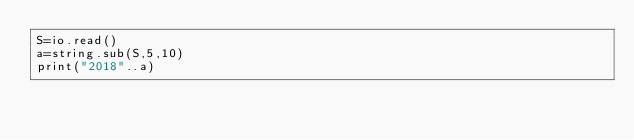Convert code to text. <code><loc_0><loc_0><loc_500><loc_500><_Lua_>S=io.read()
a=string.sub(S,5,10)
print("2018"..a)</code> 